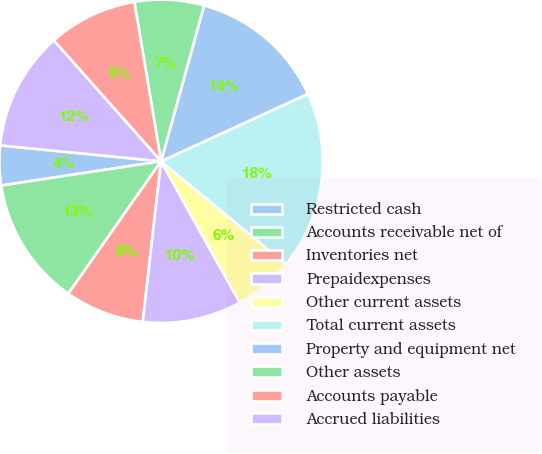Convert chart. <chart><loc_0><loc_0><loc_500><loc_500><pie_chart><fcel>Restricted cash<fcel>Accounts receivable net of<fcel>Inventories net<fcel>Prepaidexpenses<fcel>Other current assets<fcel>Total current assets<fcel>Property and equipment net<fcel>Other assets<fcel>Accounts payable<fcel>Accrued liabilities<nl><fcel>3.96%<fcel>12.87%<fcel>7.92%<fcel>9.9%<fcel>5.94%<fcel>17.82%<fcel>13.86%<fcel>6.93%<fcel>8.91%<fcel>11.88%<nl></chart> 